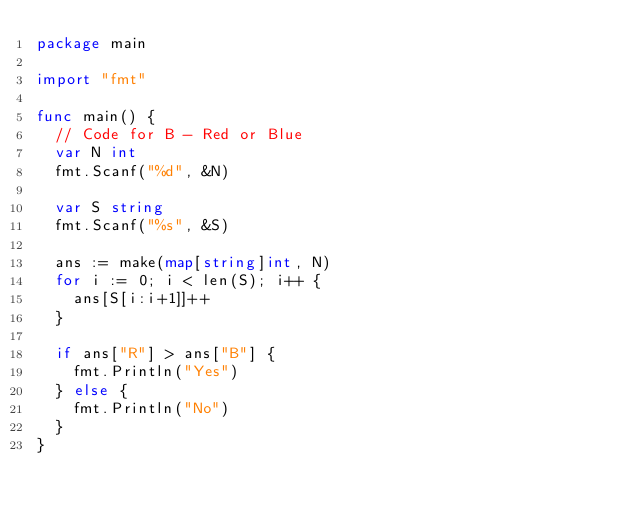Convert code to text. <code><loc_0><loc_0><loc_500><loc_500><_Go_>package main

import "fmt"

func main() {
	// Code for B - Red or Blue
	var N int
	fmt.Scanf("%d", &N)

	var S string
	fmt.Scanf("%s", &S)

	ans := make(map[string]int, N)
	for i := 0; i < len(S); i++ {
		ans[S[i:i+1]]++
	}

	if ans["R"] > ans["B"] {
		fmt.Println("Yes")
	} else {
		fmt.Println("No")
	}
}
</code> 